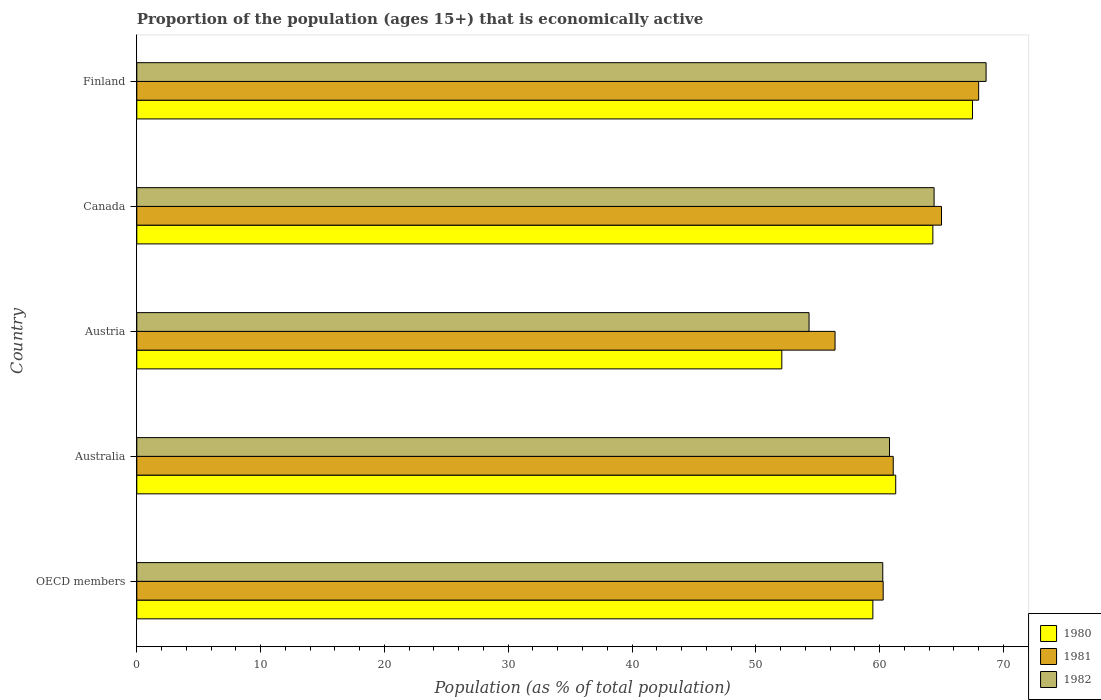Are the number of bars on each tick of the Y-axis equal?
Keep it short and to the point. Yes. Across all countries, what is the minimum proportion of the population that is economically active in 1980?
Keep it short and to the point. 52.1. In which country was the proportion of the population that is economically active in 1981 minimum?
Provide a succinct answer. Austria. What is the total proportion of the population that is economically active in 1982 in the graph?
Your answer should be compact. 308.35. What is the difference between the proportion of the population that is economically active in 1980 in Australia and that in Finland?
Your answer should be very brief. -6.2. What is the difference between the proportion of the population that is economically active in 1980 in Finland and the proportion of the population that is economically active in 1982 in Australia?
Offer a very short reply. 6.7. What is the average proportion of the population that is economically active in 1982 per country?
Provide a succinct answer. 61.67. What is the difference between the proportion of the population that is economically active in 1980 and proportion of the population that is economically active in 1982 in Finland?
Ensure brevity in your answer.  -1.1. What is the ratio of the proportion of the population that is economically active in 1982 in Austria to that in Finland?
Ensure brevity in your answer.  0.79. Is the difference between the proportion of the population that is economically active in 1980 in Canada and Finland greater than the difference between the proportion of the population that is economically active in 1982 in Canada and Finland?
Provide a succinct answer. Yes. What is the difference between the highest and the second highest proportion of the population that is economically active in 1980?
Your response must be concise. 3.2. What is the difference between the highest and the lowest proportion of the population that is economically active in 1982?
Ensure brevity in your answer.  14.3. In how many countries, is the proportion of the population that is economically active in 1980 greater than the average proportion of the population that is economically active in 1980 taken over all countries?
Make the answer very short. 3. Is the sum of the proportion of the population that is economically active in 1982 in Canada and Finland greater than the maximum proportion of the population that is economically active in 1981 across all countries?
Provide a succinct answer. Yes. What does the 3rd bar from the top in Finland represents?
Keep it short and to the point. 1980. What does the 2nd bar from the bottom in Finland represents?
Your answer should be very brief. 1981. Is it the case that in every country, the sum of the proportion of the population that is economically active in 1981 and proportion of the population that is economically active in 1982 is greater than the proportion of the population that is economically active in 1980?
Keep it short and to the point. Yes. How many bars are there?
Make the answer very short. 15. What is the difference between two consecutive major ticks on the X-axis?
Offer a very short reply. 10. Are the values on the major ticks of X-axis written in scientific E-notation?
Give a very brief answer. No. How many legend labels are there?
Offer a very short reply. 3. How are the legend labels stacked?
Provide a succinct answer. Vertical. What is the title of the graph?
Provide a succinct answer. Proportion of the population (ages 15+) that is economically active. Does "1995" appear as one of the legend labels in the graph?
Ensure brevity in your answer.  No. What is the label or title of the X-axis?
Your answer should be compact. Population (as % of total population). What is the Population (as % of total population) in 1980 in OECD members?
Make the answer very short. 59.45. What is the Population (as % of total population) of 1981 in OECD members?
Your response must be concise. 60.29. What is the Population (as % of total population) in 1982 in OECD members?
Keep it short and to the point. 60.25. What is the Population (as % of total population) of 1980 in Australia?
Ensure brevity in your answer.  61.3. What is the Population (as % of total population) in 1981 in Australia?
Give a very brief answer. 61.1. What is the Population (as % of total population) in 1982 in Australia?
Offer a very short reply. 60.8. What is the Population (as % of total population) in 1980 in Austria?
Offer a very short reply. 52.1. What is the Population (as % of total population) in 1981 in Austria?
Offer a terse response. 56.4. What is the Population (as % of total population) in 1982 in Austria?
Keep it short and to the point. 54.3. What is the Population (as % of total population) in 1980 in Canada?
Offer a terse response. 64.3. What is the Population (as % of total population) of 1982 in Canada?
Provide a short and direct response. 64.4. What is the Population (as % of total population) in 1980 in Finland?
Make the answer very short. 67.5. What is the Population (as % of total population) in 1982 in Finland?
Your response must be concise. 68.6. Across all countries, what is the maximum Population (as % of total population) in 1980?
Offer a very short reply. 67.5. Across all countries, what is the maximum Population (as % of total population) in 1981?
Your answer should be compact. 68. Across all countries, what is the maximum Population (as % of total population) in 1982?
Offer a terse response. 68.6. Across all countries, what is the minimum Population (as % of total population) of 1980?
Keep it short and to the point. 52.1. Across all countries, what is the minimum Population (as % of total population) in 1981?
Your response must be concise. 56.4. Across all countries, what is the minimum Population (as % of total population) of 1982?
Offer a very short reply. 54.3. What is the total Population (as % of total population) in 1980 in the graph?
Give a very brief answer. 304.65. What is the total Population (as % of total population) in 1981 in the graph?
Offer a terse response. 310.79. What is the total Population (as % of total population) in 1982 in the graph?
Offer a very short reply. 308.35. What is the difference between the Population (as % of total population) in 1980 in OECD members and that in Australia?
Keep it short and to the point. -1.85. What is the difference between the Population (as % of total population) of 1981 in OECD members and that in Australia?
Offer a terse response. -0.81. What is the difference between the Population (as % of total population) in 1982 in OECD members and that in Australia?
Keep it short and to the point. -0.55. What is the difference between the Population (as % of total population) of 1980 in OECD members and that in Austria?
Offer a very short reply. 7.35. What is the difference between the Population (as % of total population) of 1981 in OECD members and that in Austria?
Keep it short and to the point. 3.89. What is the difference between the Population (as % of total population) in 1982 in OECD members and that in Austria?
Ensure brevity in your answer.  5.95. What is the difference between the Population (as % of total population) in 1980 in OECD members and that in Canada?
Your answer should be compact. -4.85. What is the difference between the Population (as % of total population) in 1981 in OECD members and that in Canada?
Ensure brevity in your answer.  -4.71. What is the difference between the Population (as % of total population) in 1982 in OECD members and that in Canada?
Ensure brevity in your answer.  -4.15. What is the difference between the Population (as % of total population) of 1980 in OECD members and that in Finland?
Your response must be concise. -8.05. What is the difference between the Population (as % of total population) of 1981 in OECD members and that in Finland?
Keep it short and to the point. -7.71. What is the difference between the Population (as % of total population) in 1982 in OECD members and that in Finland?
Offer a terse response. -8.35. What is the difference between the Population (as % of total population) of 1980 in Australia and that in Austria?
Make the answer very short. 9.2. What is the difference between the Population (as % of total population) in 1981 in Australia and that in Austria?
Provide a short and direct response. 4.7. What is the difference between the Population (as % of total population) of 1980 in Australia and that in Canada?
Your response must be concise. -3. What is the difference between the Population (as % of total population) in 1980 in Australia and that in Finland?
Ensure brevity in your answer.  -6.2. What is the difference between the Population (as % of total population) in 1982 in Australia and that in Finland?
Offer a very short reply. -7.8. What is the difference between the Population (as % of total population) in 1980 in Austria and that in Finland?
Give a very brief answer. -15.4. What is the difference between the Population (as % of total population) of 1982 in Austria and that in Finland?
Provide a succinct answer. -14.3. What is the difference between the Population (as % of total population) in 1981 in Canada and that in Finland?
Your response must be concise. -3. What is the difference between the Population (as % of total population) of 1982 in Canada and that in Finland?
Your answer should be very brief. -4.2. What is the difference between the Population (as % of total population) of 1980 in OECD members and the Population (as % of total population) of 1981 in Australia?
Provide a succinct answer. -1.65. What is the difference between the Population (as % of total population) in 1980 in OECD members and the Population (as % of total population) in 1982 in Australia?
Make the answer very short. -1.35. What is the difference between the Population (as % of total population) in 1981 in OECD members and the Population (as % of total population) in 1982 in Australia?
Your response must be concise. -0.51. What is the difference between the Population (as % of total population) in 1980 in OECD members and the Population (as % of total population) in 1981 in Austria?
Give a very brief answer. 3.05. What is the difference between the Population (as % of total population) in 1980 in OECD members and the Population (as % of total population) in 1982 in Austria?
Offer a terse response. 5.15. What is the difference between the Population (as % of total population) of 1981 in OECD members and the Population (as % of total population) of 1982 in Austria?
Offer a terse response. 5.99. What is the difference between the Population (as % of total population) of 1980 in OECD members and the Population (as % of total population) of 1981 in Canada?
Your answer should be compact. -5.55. What is the difference between the Population (as % of total population) in 1980 in OECD members and the Population (as % of total population) in 1982 in Canada?
Provide a succinct answer. -4.95. What is the difference between the Population (as % of total population) in 1981 in OECD members and the Population (as % of total population) in 1982 in Canada?
Give a very brief answer. -4.11. What is the difference between the Population (as % of total population) in 1980 in OECD members and the Population (as % of total population) in 1981 in Finland?
Provide a short and direct response. -8.55. What is the difference between the Population (as % of total population) in 1980 in OECD members and the Population (as % of total population) in 1982 in Finland?
Your response must be concise. -9.15. What is the difference between the Population (as % of total population) in 1981 in OECD members and the Population (as % of total population) in 1982 in Finland?
Provide a succinct answer. -8.31. What is the difference between the Population (as % of total population) in 1980 in Australia and the Population (as % of total population) in 1982 in Austria?
Provide a short and direct response. 7. What is the difference between the Population (as % of total population) of 1980 in Australia and the Population (as % of total population) of 1982 in Canada?
Keep it short and to the point. -3.1. What is the difference between the Population (as % of total population) of 1981 in Australia and the Population (as % of total population) of 1982 in Canada?
Your answer should be compact. -3.3. What is the difference between the Population (as % of total population) of 1980 in Australia and the Population (as % of total population) of 1982 in Finland?
Provide a succinct answer. -7.3. What is the difference between the Population (as % of total population) of 1981 in Australia and the Population (as % of total population) of 1982 in Finland?
Offer a very short reply. -7.5. What is the difference between the Population (as % of total population) of 1980 in Austria and the Population (as % of total population) of 1981 in Canada?
Offer a very short reply. -12.9. What is the difference between the Population (as % of total population) of 1980 in Austria and the Population (as % of total population) of 1982 in Canada?
Offer a very short reply. -12.3. What is the difference between the Population (as % of total population) in 1981 in Austria and the Population (as % of total population) in 1982 in Canada?
Provide a succinct answer. -8. What is the difference between the Population (as % of total population) in 1980 in Austria and the Population (as % of total population) in 1981 in Finland?
Your answer should be very brief. -15.9. What is the difference between the Population (as % of total population) of 1980 in Austria and the Population (as % of total population) of 1982 in Finland?
Your response must be concise. -16.5. What is the difference between the Population (as % of total population) of 1981 in Austria and the Population (as % of total population) of 1982 in Finland?
Make the answer very short. -12.2. What is the difference between the Population (as % of total population) of 1980 in Canada and the Population (as % of total population) of 1981 in Finland?
Ensure brevity in your answer.  -3.7. What is the difference between the Population (as % of total population) in 1980 in Canada and the Population (as % of total population) in 1982 in Finland?
Your answer should be very brief. -4.3. What is the average Population (as % of total population) of 1980 per country?
Your answer should be very brief. 60.93. What is the average Population (as % of total population) of 1981 per country?
Ensure brevity in your answer.  62.16. What is the average Population (as % of total population) in 1982 per country?
Offer a very short reply. 61.67. What is the difference between the Population (as % of total population) of 1980 and Population (as % of total population) of 1981 in OECD members?
Keep it short and to the point. -0.83. What is the difference between the Population (as % of total population) in 1980 and Population (as % of total population) in 1982 in OECD members?
Ensure brevity in your answer.  -0.8. What is the difference between the Population (as % of total population) of 1981 and Population (as % of total population) of 1982 in OECD members?
Your response must be concise. 0.03. What is the difference between the Population (as % of total population) in 1980 and Population (as % of total population) in 1982 in Australia?
Provide a succinct answer. 0.5. What is the difference between the Population (as % of total population) of 1980 and Population (as % of total population) of 1982 in Austria?
Keep it short and to the point. -2.2. What is the difference between the Population (as % of total population) in 1980 and Population (as % of total population) in 1982 in Canada?
Offer a terse response. -0.1. What is the difference between the Population (as % of total population) of 1980 and Population (as % of total population) of 1981 in Finland?
Make the answer very short. -0.5. What is the difference between the Population (as % of total population) in 1980 and Population (as % of total population) in 1982 in Finland?
Provide a succinct answer. -1.1. What is the ratio of the Population (as % of total population) of 1980 in OECD members to that in Australia?
Your response must be concise. 0.97. What is the ratio of the Population (as % of total population) in 1981 in OECD members to that in Australia?
Provide a short and direct response. 0.99. What is the ratio of the Population (as % of total population) in 1982 in OECD members to that in Australia?
Provide a short and direct response. 0.99. What is the ratio of the Population (as % of total population) in 1980 in OECD members to that in Austria?
Your answer should be compact. 1.14. What is the ratio of the Population (as % of total population) in 1981 in OECD members to that in Austria?
Make the answer very short. 1.07. What is the ratio of the Population (as % of total population) in 1982 in OECD members to that in Austria?
Offer a very short reply. 1.11. What is the ratio of the Population (as % of total population) in 1980 in OECD members to that in Canada?
Make the answer very short. 0.92. What is the ratio of the Population (as % of total population) in 1981 in OECD members to that in Canada?
Keep it short and to the point. 0.93. What is the ratio of the Population (as % of total population) in 1982 in OECD members to that in Canada?
Offer a very short reply. 0.94. What is the ratio of the Population (as % of total population) of 1980 in OECD members to that in Finland?
Offer a very short reply. 0.88. What is the ratio of the Population (as % of total population) in 1981 in OECD members to that in Finland?
Keep it short and to the point. 0.89. What is the ratio of the Population (as % of total population) in 1982 in OECD members to that in Finland?
Keep it short and to the point. 0.88. What is the ratio of the Population (as % of total population) of 1980 in Australia to that in Austria?
Offer a terse response. 1.18. What is the ratio of the Population (as % of total population) in 1981 in Australia to that in Austria?
Give a very brief answer. 1.08. What is the ratio of the Population (as % of total population) of 1982 in Australia to that in Austria?
Your answer should be very brief. 1.12. What is the ratio of the Population (as % of total population) of 1980 in Australia to that in Canada?
Provide a succinct answer. 0.95. What is the ratio of the Population (as % of total population) of 1982 in Australia to that in Canada?
Your answer should be very brief. 0.94. What is the ratio of the Population (as % of total population) of 1980 in Australia to that in Finland?
Make the answer very short. 0.91. What is the ratio of the Population (as % of total population) in 1981 in Australia to that in Finland?
Your response must be concise. 0.9. What is the ratio of the Population (as % of total population) in 1982 in Australia to that in Finland?
Offer a very short reply. 0.89. What is the ratio of the Population (as % of total population) in 1980 in Austria to that in Canada?
Your answer should be compact. 0.81. What is the ratio of the Population (as % of total population) of 1981 in Austria to that in Canada?
Offer a very short reply. 0.87. What is the ratio of the Population (as % of total population) in 1982 in Austria to that in Canada?
Provide a short and direct response. 0.84. What is the ratio of the Population (as % of total population) in 1980 in Austria to that in Finland?
Keep it short and to the point. 0.77. What is the ratio of the Population (as % of total population) of 1981 in Austria to that in Finland?
Your answer should be compact. 0.83. What is the ratio of the Population (as % of total population) in 1982 in Austria to that in Finland?
Offer a very short reply. 0.79. What is the ratio of the Population (as % of total population) of 1980 in Canada to that in Finland?
Keep it short and to the point. 0.95. What is the ratio of the Population (as % of total population) of 1981 in Canada to that in Finland?
Your answer should be very brief. 0.96. What is the ratio of the Population (as % of total population) of 1982 in Canada to that in Finland?
Make the answer very short. 0.94. What is the difference between the highest and the second highest Population (as % of total population) in 1981?
Your answer should be compact. 3. What is the difference between the highest and the lowest Population (as % of total population) of 1980?
Provide a short and direct response. 15.4. What is the difference between the highest and the lowest Population (as % of total population) of 1981?
Provide a succinct answer. 11.6. What is the difference between the highest and the lowest Population (as % of total population) of 1982?
Provide a short and direct response. 14.3. 